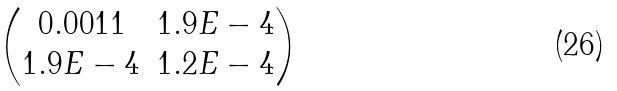Convert formula to latex. <formula><loc_0><loc_0><loc_500><loc_500>\begin{pmatrix} 0 . 0 0 1 1 & 1 . 9 E - 4 \\ 1 . 9 E - 4 & 1 . 2 E - 4 \end{pmatrix}</formula> 